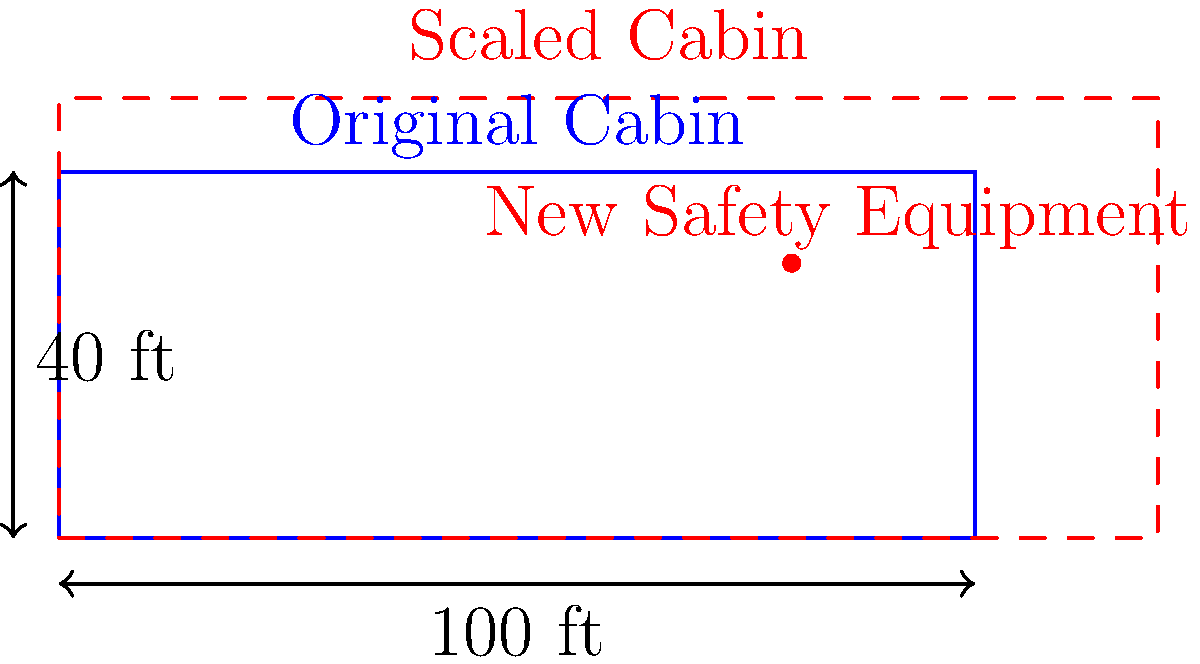A new safety regulation requires the installation of additional equipment in aircraft cabins, necessitating a cabin expansion. If the original cabin dimensions are 100 feet long and 40 feet wide, and a uniform scaling factor of 1.2 is applied to accommodate the new equipment, what will be the area of the scaled cabin in square feet? To solve this problem, we'll follow these steps:

1. Calculate the area of the original cabin:
   Original area = length × width
   $A_1 = 100 \text{ ft} \times 40 \text{ ft} = 4000 \text{ sq ft}$

2. Determine the effect of scaling on area:
   When a two-dimensional figure is scaled by a factor of $k$, its area is scaled by a factor of $k^2$.
   In this case, $k = 1.2$

3. Calculate the scaling factor for the area:
   Area scaling factor = $k^2 = 1.2^2 = 1.44$

4. Compute the area of the scaled cabin:
   Scaled area = Original area × Area scaling factor
   $A_2 = 4000 \text{ sq ft} \times 1.44 = 5760 \text{ sq ft}$

Therefore, the area of the scaled cabin will be 5760 square feet.
Answer: 5760 sq ft 